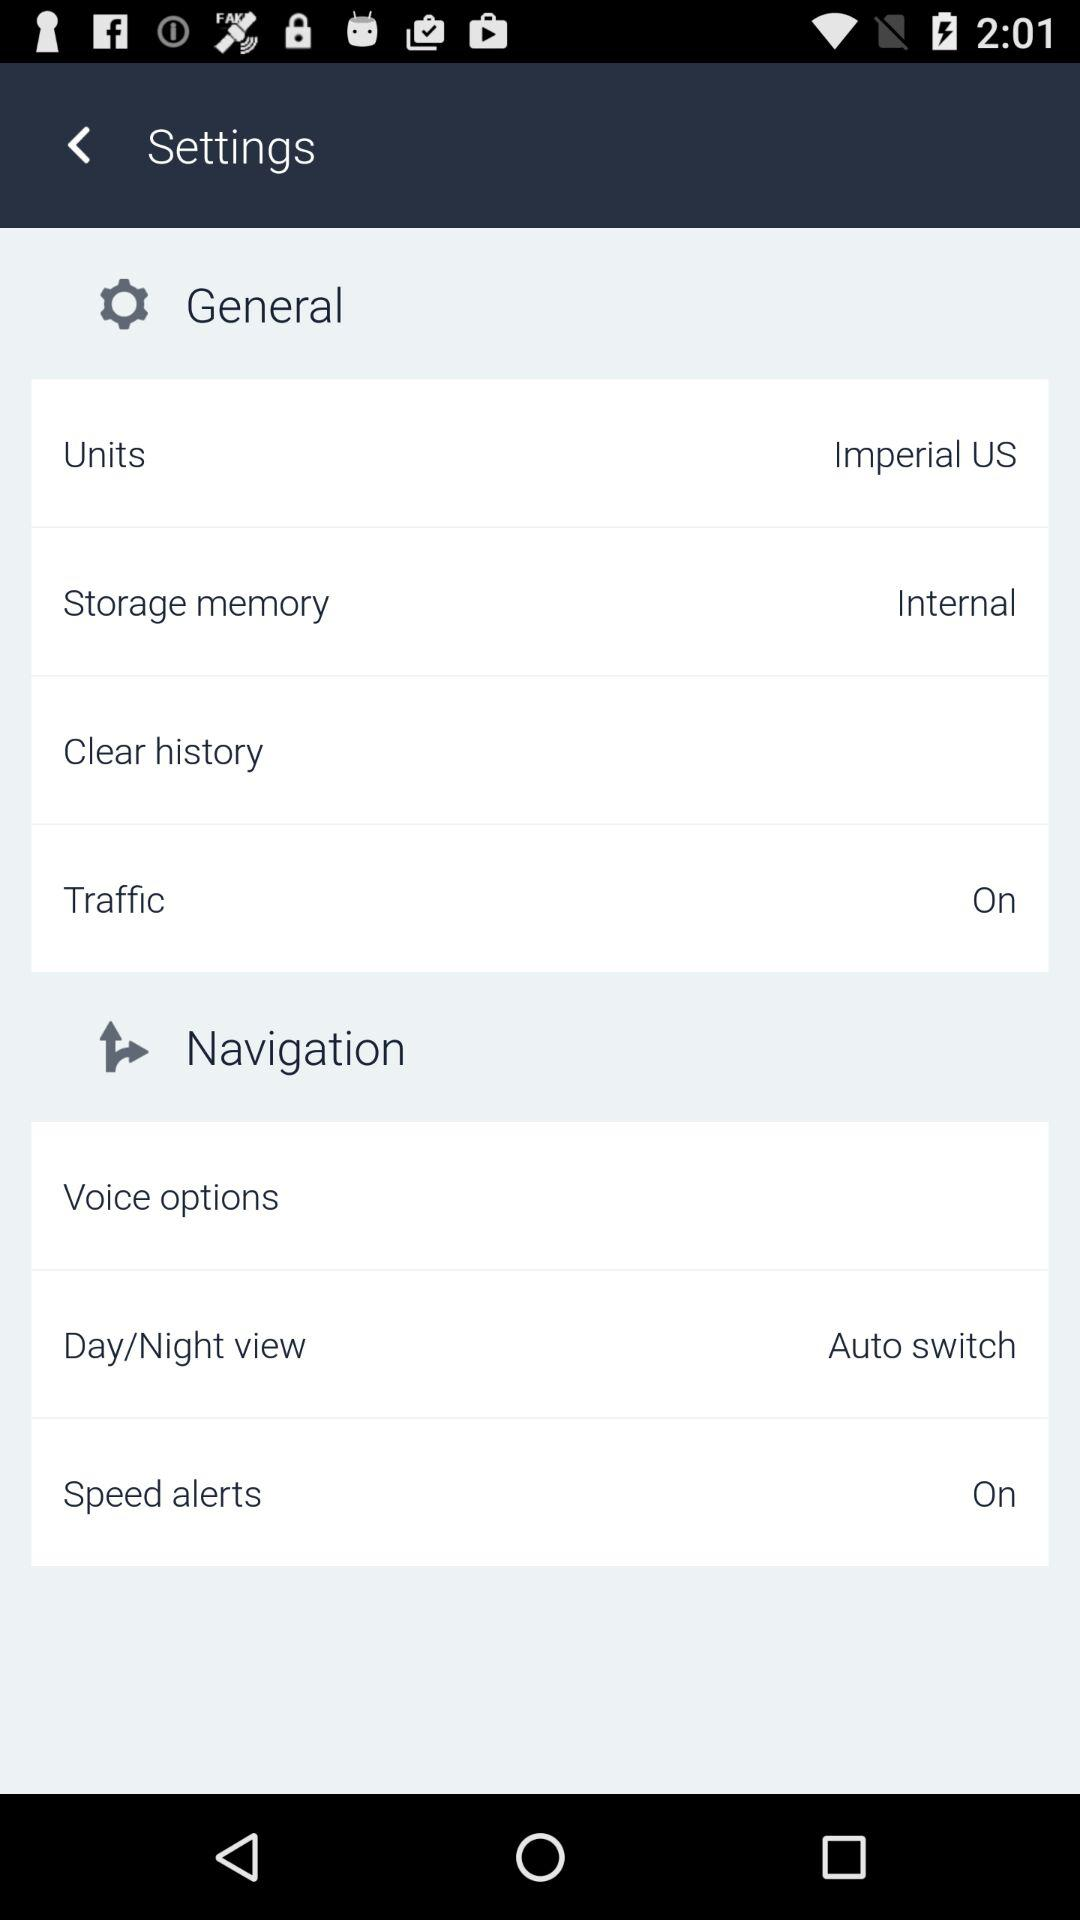What is the status of the "Speed alerts"? The status is "on". 